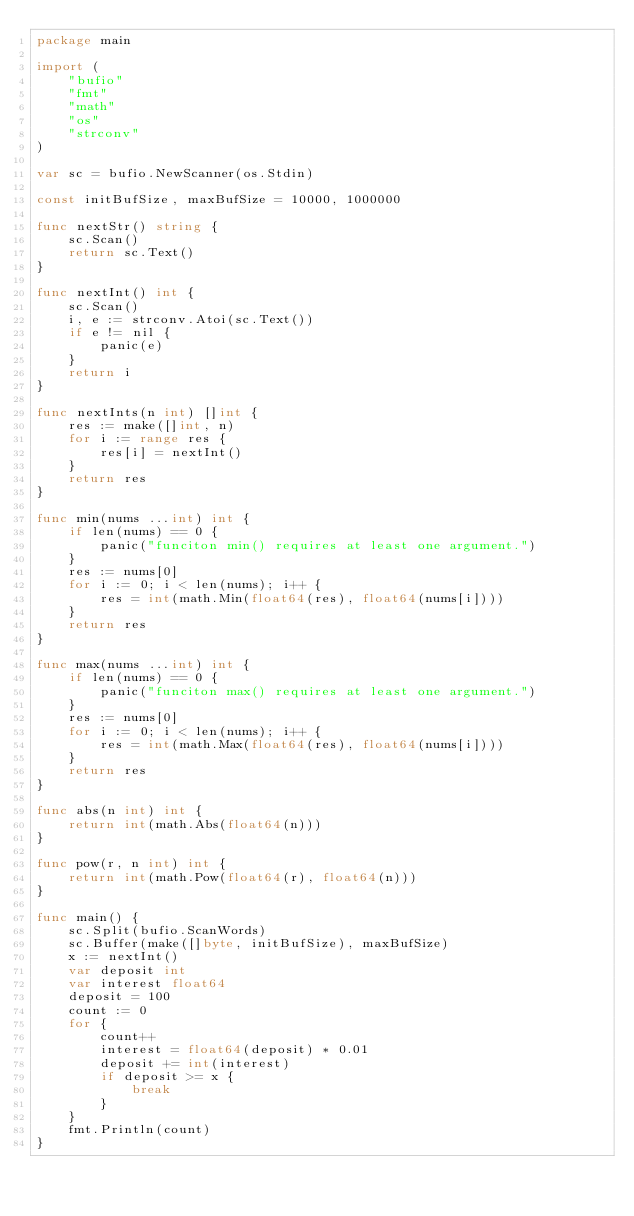<code> <loc_0><loc_0><loc_500><loc_500><_Go_>package main

import (
	"bufio"
	"fmt"
	"math"
	"os"
	"strconv"
)

var sc = bufio.NewScanner(os.Stdin)

const initBufSize, maxBufSize = 10000, 1000000

func nextStr() string {
	sc.Scan()
	return sc.Text()
}

func nextInt() int {
	sc.Scan()
	i, e := strconv.Atoi(sc.Text())
	if e != nil {
		panic(e)
	}
	return i
}

func nextInts(n int) []int {
	res := make([]int, n)
	for i := range res {
		res[i] = nextInt()
	}
	return res
}

func min(nums ...int) int {
	if len(nums) == 0 {
		panic("funciton min() requires at least one argument.")
	}
	res := nums[0]
	for i := 0; i < len(nums); i++ {
		res = int(math.Min(float64(res), float64(nums[i])))
	}
	return res
}

func max(nums ...int) int {
	if len(nums) == 0 {
		panic("funciton max() requires at least one argument.")
	}
	res := nums[0]
	for i := 0; i < len(nums); i++ {
		res = int(math.Max(float64(res), float64(nums[i])))
	}
	return res
}

func abs(n int) int {
	return int(math.Abs(float64(n)))
}

func pow(r, n int) int {
	return int(math.Pow(float64(r), float64(n)))
}

func main() {
	sc.Split(bufio.ScanWords)
	sc.Buffer(make([]byte, initBufSize), maxBufSize)
	x := nextInt()
	var deposit int
	var interest float64
	deposit = 100
	count := 0
	for {
		count++
		interest = float64(deposit) * 0.01
		deposit += int(interest)
		if deposit >= x {
			break
		}
	}
	fmt.Println(count)
}
</code> 